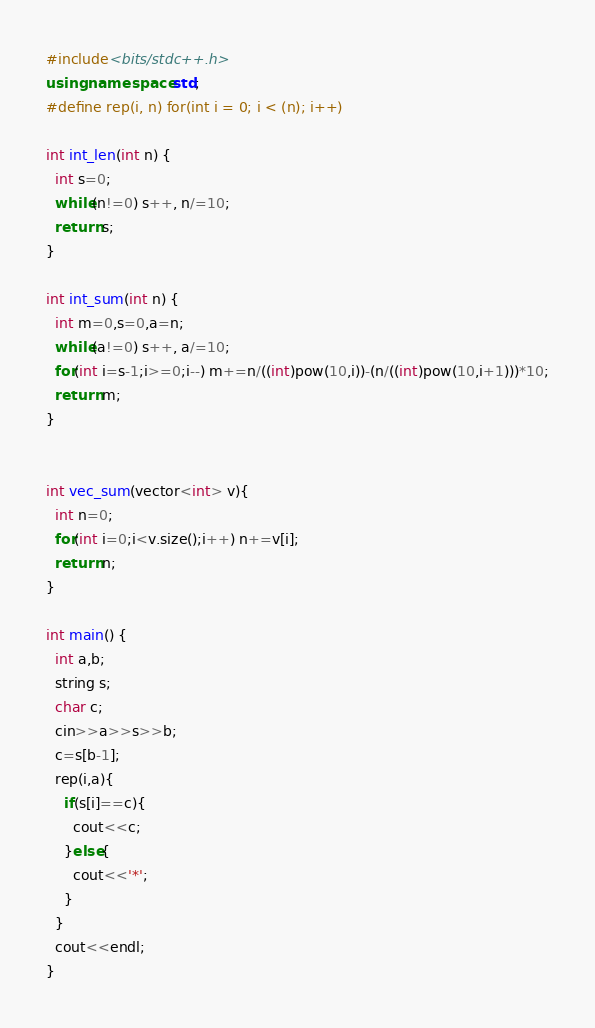Convert code to text. <code><loc_0><loc_0><loc_500><loc_500><_C++_>#include<bits/stdc++.h>
using namespace std;
#define rep(i, n) for(int i = 0; i < (n); i++)

int int_len(int n) {
  int s=0;
  while(n!=0) s++, n/=10;
  return s;
}

int int_sum(int n) {
  int m=0,s=0,a=n;
  while(a!=0) s++, a/=10;
  for(int i=s-1;i>=0;i--) m+=n/((int)pow(10,i))-(n/((int)pow(10,i+1)))*10;
  return m;
}


int vec_sum(vector<int> v){
  int n=0;
  for(int i=0;i<v.size();i++) n+=v[i];
  return n;
}

int main() {
  int a,b;
  string s;
  char c;
  cin>>a>>s>>b;
  c=s[b-1];
  rep(i,a){
    if(s[i]==c){
      cout<<c;
    }else{
      cout<<'*';
    }
  }
  cout<<endl;
}</code> 